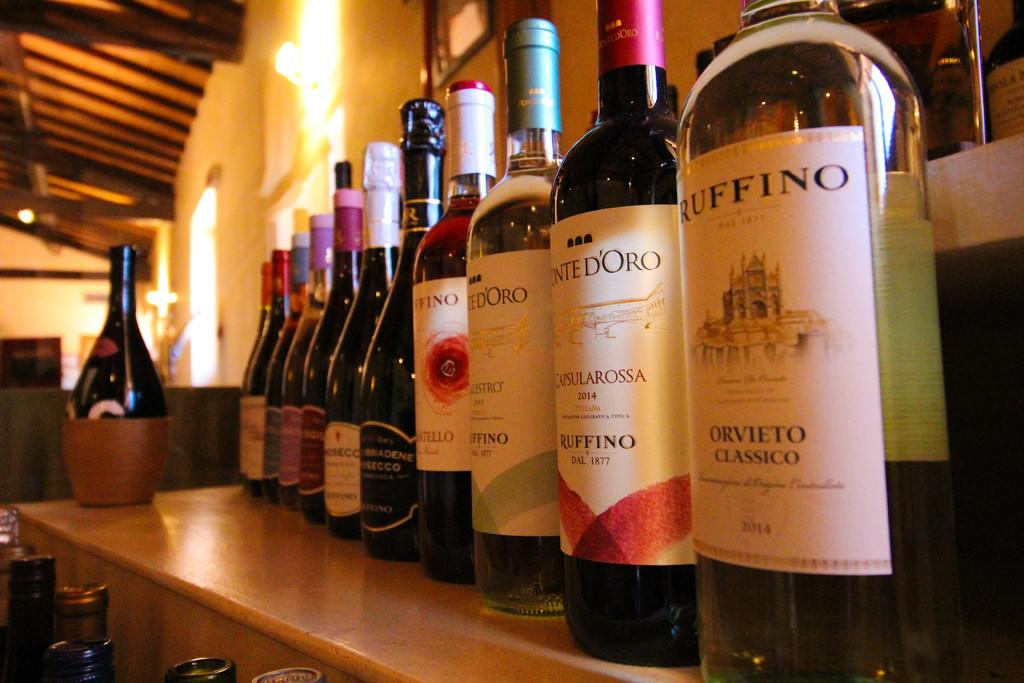Provide a one-sentence caption for the provided image. A wine display has a bottle of Orvieto Classico from 2014. 